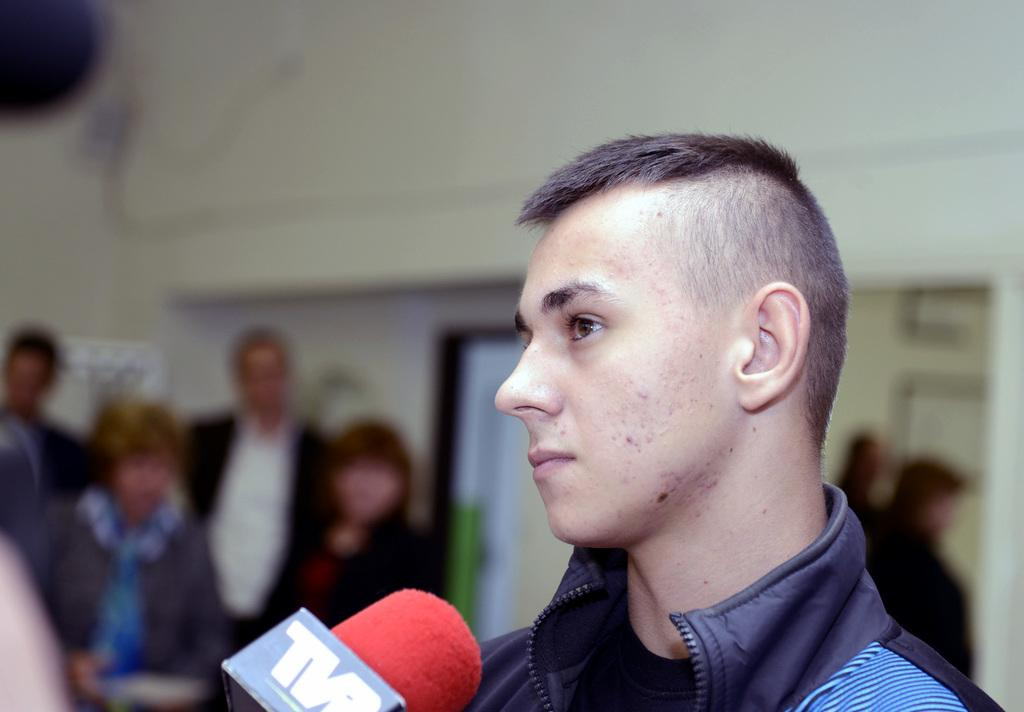What is the person in the image wearing? The person in the image is wearing a blue jacket. What object is in front of the person? There is a microphone in front of the person. Can you describe the people visible in the background? There are other persons visible in the background. What color is the wall in the background? The wall in the background is white. Reasoning: Let's think step by step by step in order to produce the conversation. We start by identifying the main subject in the image, which is the person wearing a blue jacket. Then, we expand the conversation to include other objects and people visible in the image, such as the microphone and the persons in the background. We also describe the color of the wall in the background. Each question is designed to elicit a specific detail about the image that is known from the provided facts. Absurd Question/Answer: How does the person in the image use the brake to control the fog in the image? There is no fog or brake present in the image; it features a person with a microphone and a white wall in the background. How does the person in the image use the brake to control the fog in the image? There is no fog or brake present in the image; it features a person with a microphone and a white wall in the background. 